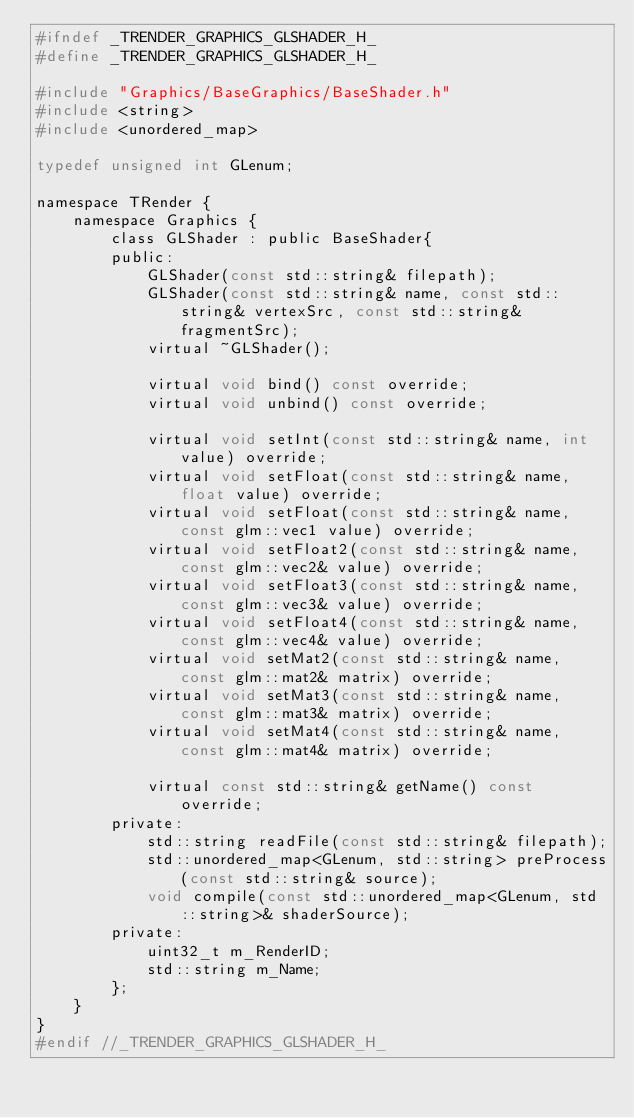Convert code to text. <code><loc_0><loc_0><loc_500><loc_500><_C_>#ifndef _TRENDER_GRAPHICS_GLSHADER_H_
#define _TRENDER_GRAPHICS_GLSHADER_H_

#include "Graphics/BaseGraphics/BaseShader.h"
#include <string>
#include <unordered_map>

typedef unsigned int GLenum;

namespace TRender {
    namespace Graphics {
        class GLShader : public BaseShader{
        public:
            GLShader(const std::string& filepath);
            GLShader(const std::string& name, const std::string& vertexSrc, const std::string& fragmentSrc);
            virtual ~GLShader();

            virtual void bind() const override;
            virtual void unbind() const override;

            virtual void setInt(const std::string& name, int value) override;
            virtual void setFloat(const std::string& name, float value) override;
            virtual void setFloat(const std::string& name, const glm::vec1 value) override;
            virtual void setFloat2(const std::string& name, const glm::vec2& value) override;
            virtual void setFloat3(const std::string& name, const glm::vec3& value) override;
            virtual void setFloat4(const std::string& name, const glm::vec4& value) override;
            virtual void setMat2(const std::string& name, const glm::mat2& matrix) override;
            virtual void setMat3(const std::string& name, const glm::mat3& matrix) override;
            virtual void setMat4(const std::string& name, const glm::mat4& matrix) override;

            virtual const std::string& getName() const override;
        private:
            std::string readFile(const std::string& filepath);
            std::unordered_map<GLenum, std::string> preProcess(const std::string& source);
            void compile(const std::unordered_map<GLenum, std::string>& shaderSource);
        private:
            uint32_t m_RenderID;
            std::string m_Name;
        };
    }
}
#endif //_TRENDER_GRAPHICS_GLSHADER_H_</code> 